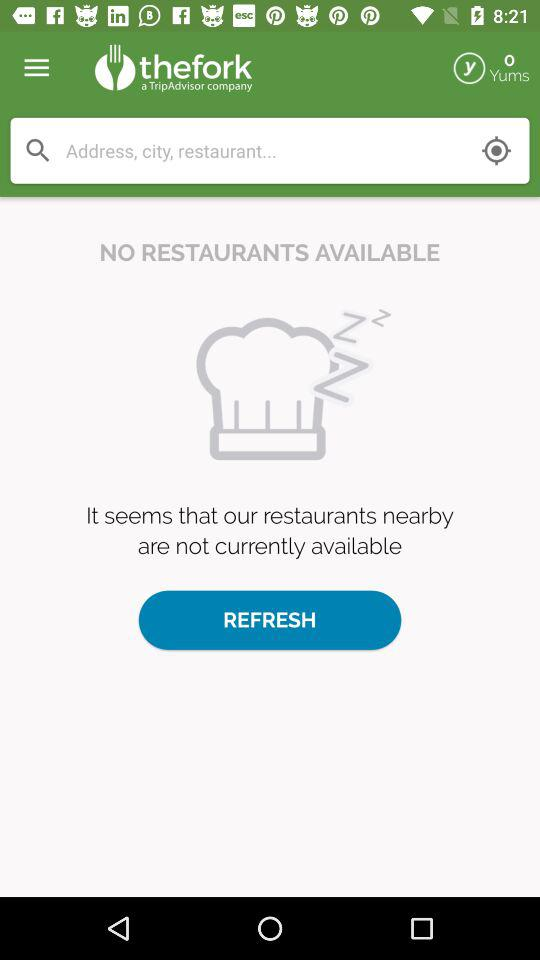Are there restaurants available? There is no restaurant available. 